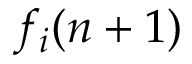<formula> <loc_0><loc_0><loc_500><loc_500>f _ { i } ( n + 1 )</formula> 